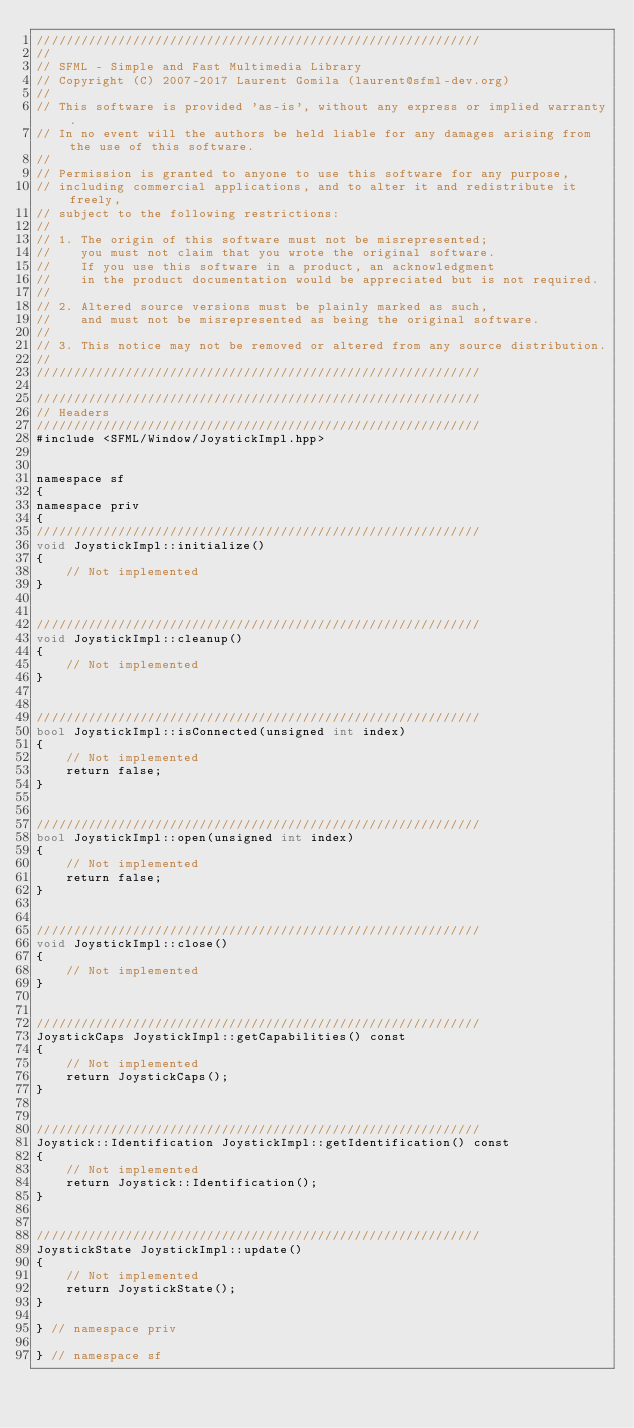<code> <loc_0><loc_0><loc_500><loc_500><_ObjectiveC_>////////////////////////////////////////////////////////////
//
// SFML - Simple and Fast Multimedia Library
// Copyright (C) 2007-2017 Laurent Gomila (laurent@sfml-dev.org)
//
// This software is provided 'as-is', without any express or implied warranty.
// In no event will the authors be held liable for any damages arising from the use of this software.
//
// Permission is granted to anyone to use this software for any purpose,
// including commercial applications, and to alter it and redistribute it freely,
// subject to the following restrictions:
//
// 1. The origin of this software must not be misrepresented;
//    you must not claim that you wrote the original software.
//    If you use this software in a product, an acknowledgment
//    in the product documentation would be appreciated but is not required.
//
// 2. Altered source versions must be plainly marked as such,
//    and must not be misrepresented as being the original software.
//
// 3. This notice may not be removed or altered from any source distribution.
//
////////////////////////////////////////////////////////////

////////////////////////////////////////////////////////////
// Headers
////////////////////////////////////////////////////////////
#include <SFML/Window/JoystickImpl.hpp>


namespace sf
{
namespace priv
{
////////////////////////////////////////////////////////////
void JoystickImpl::initialize()
{
    // Not implemented
}


////////////////////////////////////////////////////////////
void JoystickImpl::cleanup()
{
    // Not implemented
}


////////////////////////////////////////////////////////////
bool JoystickImpl::isConnected(unsigned int index)
{
    // Not implemented
    return false;
}


////////////////////////////////////////////////////////////
bool JoystickImpl::open(unsigned int index)
{
    // Not implemented
    return false;
}


////////////////////////////////////////////////////////////
void JoystickImpl::close()
{
    // Not implemented
}


////////////////////////////////////////////////////////////
JoystickCaps JoystickImpl::getCapabilities() const
{
    // Not implemented
    return JoystickCaps();
}


////////////////////////////////////////////////////////////
Joystick::Identification JoystickImpl::getIdentification() const
{
    // Not implemented
    return Joystick::Identification();
}


////////////////////////////////////////////////////////////
JoystickState JoystickImpl::update()
{
    // Not implemented
    return JoystickState();
}

} // namespace priv

} // namespace sf
</code> 